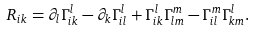Convert formula to latex. <formula><loc_0><loc_0><loc_500><loc_500>R _ { i k } = \partial _ { l } \Gamma _ { i k } ^ { l } - \partial _ { k } \Gamma _ { i l } ^ { l } + \Gamma _ { i k } ^ { l } \Gamma _ { l m } ^ { m } - \Gamma _ { i l } ^ { m } \Gamma _ { k m } ^ { l } .</formula> 